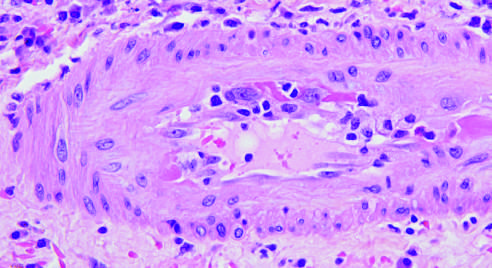s an arteriole shown with inflammatory cells attacking and undermining the endothelium arrow?
Answer the question using a single word or phrase. Yes 